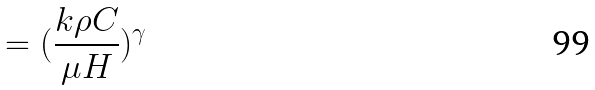<formula> <loc_0><loc_0><loc_500><loc_500>= ( \frac { k \rho C } { \mu H } ) ^ { \gamma }</formula> 